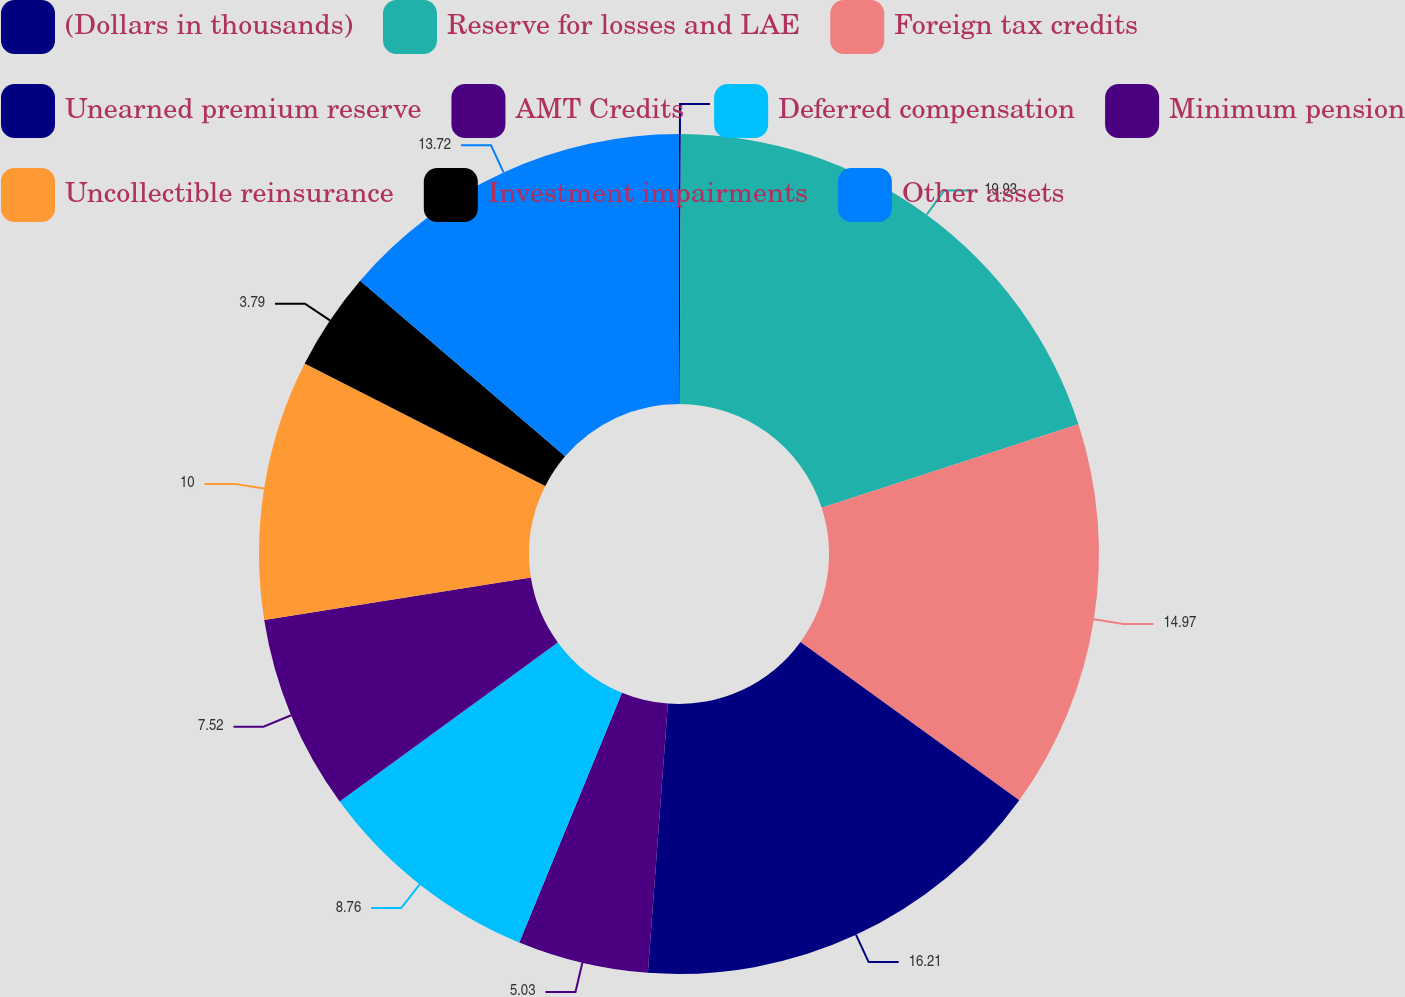<chart> <loc_0><loc_0><loc_500><loc_500><pie_chart><fcel>(Dollars in thousands)<fcel>Reserve for losses and LAE<fcel>Foreign tax credits<fcel>Unearned premium reserve<fcel>AMT Credits<fcel>Deferred compensation<fcel>Minimum pension<fcel>Uncollectible reinsurance<fcel>Investment impairments<fcel>Other assets<nl><fcel>0.07%<fcel>19.93%<fcel>14.97%<fcel>16.21%<fcel>5.03%<fcel>8.76%<fcel>7.52%<fcel>10.0%<fcel>3.79%<fcel>13.72%<nl></chart> 